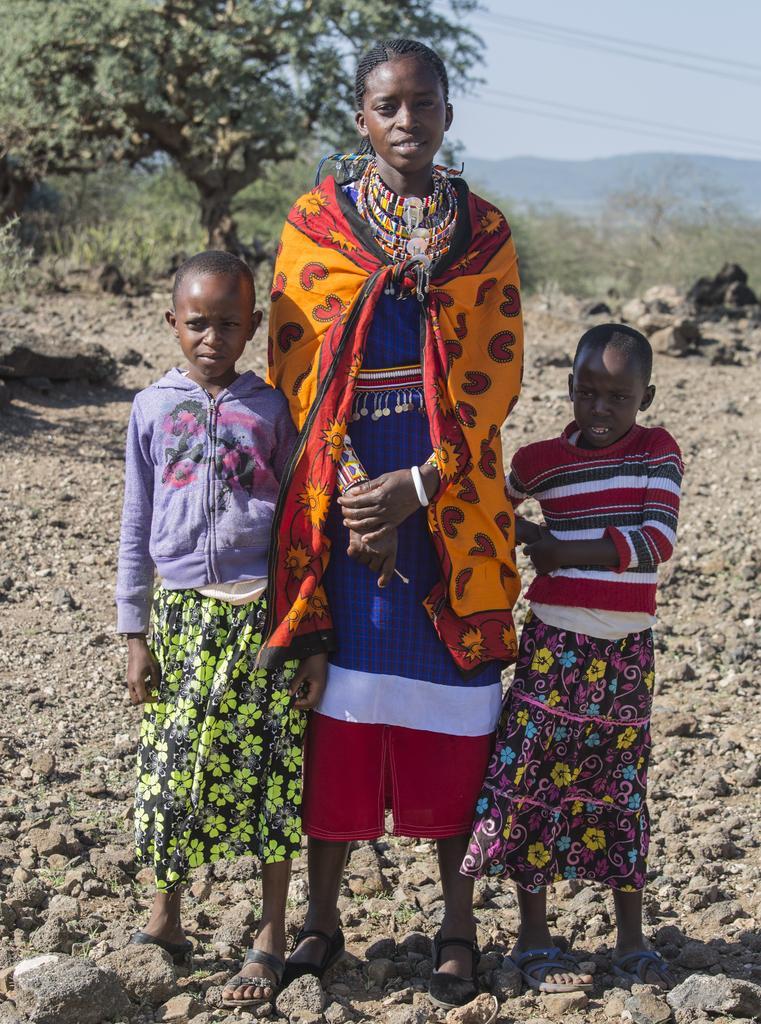Please provide a concise description of this image. In the center of the image we can see persons standing on the ground. In the background we can see trees, stones, hill and sky. 